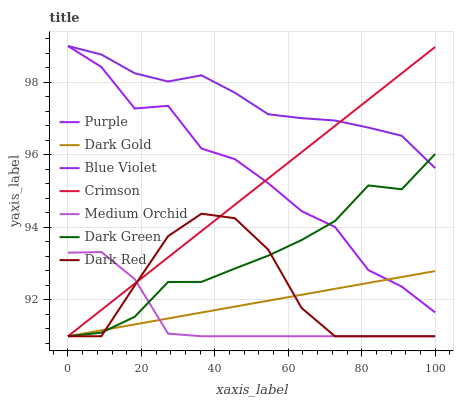Does Medium Orchid have the minimum area under the curve?
Answer yes or no. Yes. Does Blue Violet have the maximum area under the curve?
Answer yes or no. Yes. Does Purple have the minimum area under the curve?
Answer yes or no. No. Does Purple have the maximum area under the curve?
Answer yes or no. No. Is Crimson the smoothest?
Answer yes or no. Yes. Is Purple the roughest?
Answer yes or no. Yes. Is Dark Red the smoothest?
Answer yes or no. No. Is Dark Red the roughest?
Answer yes or no. No. Does Dark Gold have the lowest value?
Answer yes or no. Yes. Does Purple have the lowest value?
Answer yes or no. No. Does Blue Violet have the highest value?
Answer yes or no. Yes. Does Dark Red have the highest value?
Answer yes or no. No. Is Medium Orchid less than Purple?
Answer yes or no. Yes. Is Blue Violet greater than Dark Gold?
Answer yes or no. Yes. Does Medium Orchid intersect Dark Gold?
Answer yes or no. Yes. Is Medium Orchid less than Dark Gold?
Answer yes or no. No. Is Medium Orchid greater than Dark Gold?
Answer yes or no. No. Does Medium Orchid intersect Purple?
Answer yes or no. No. 